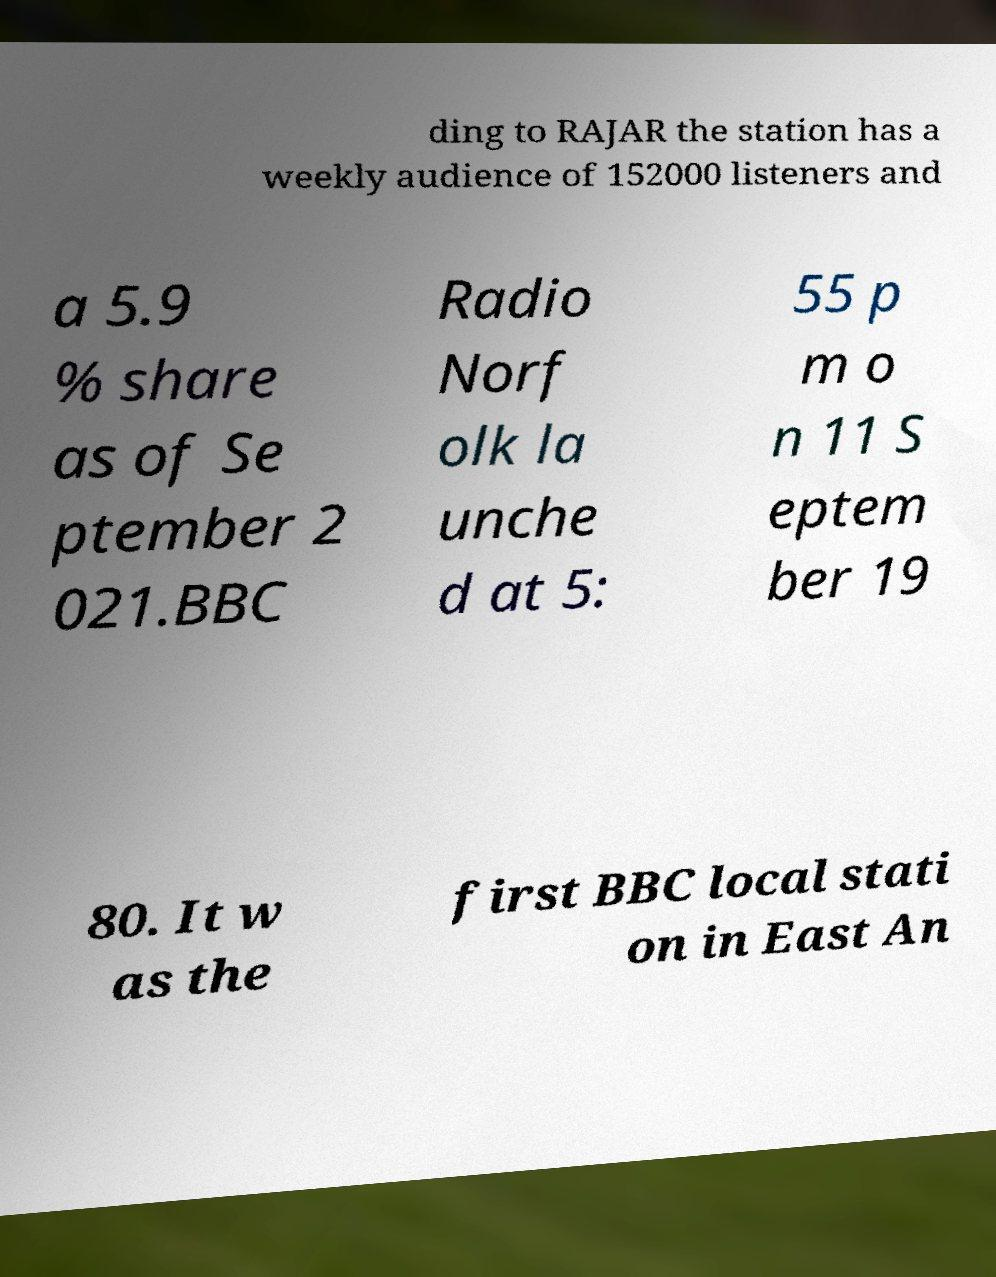For documentation purposes, I need the text within this image transcribed. Could you provide that? ding to RAJAR the station has a weekly audience of 152000 listeners and a 5.9 % share as of Se ptember 2 021.BBC Radio Norf olk la unche d at 5: 55 p m o n 11 S eptem ber 19 80. It w as the first BBC local stati on in East An 